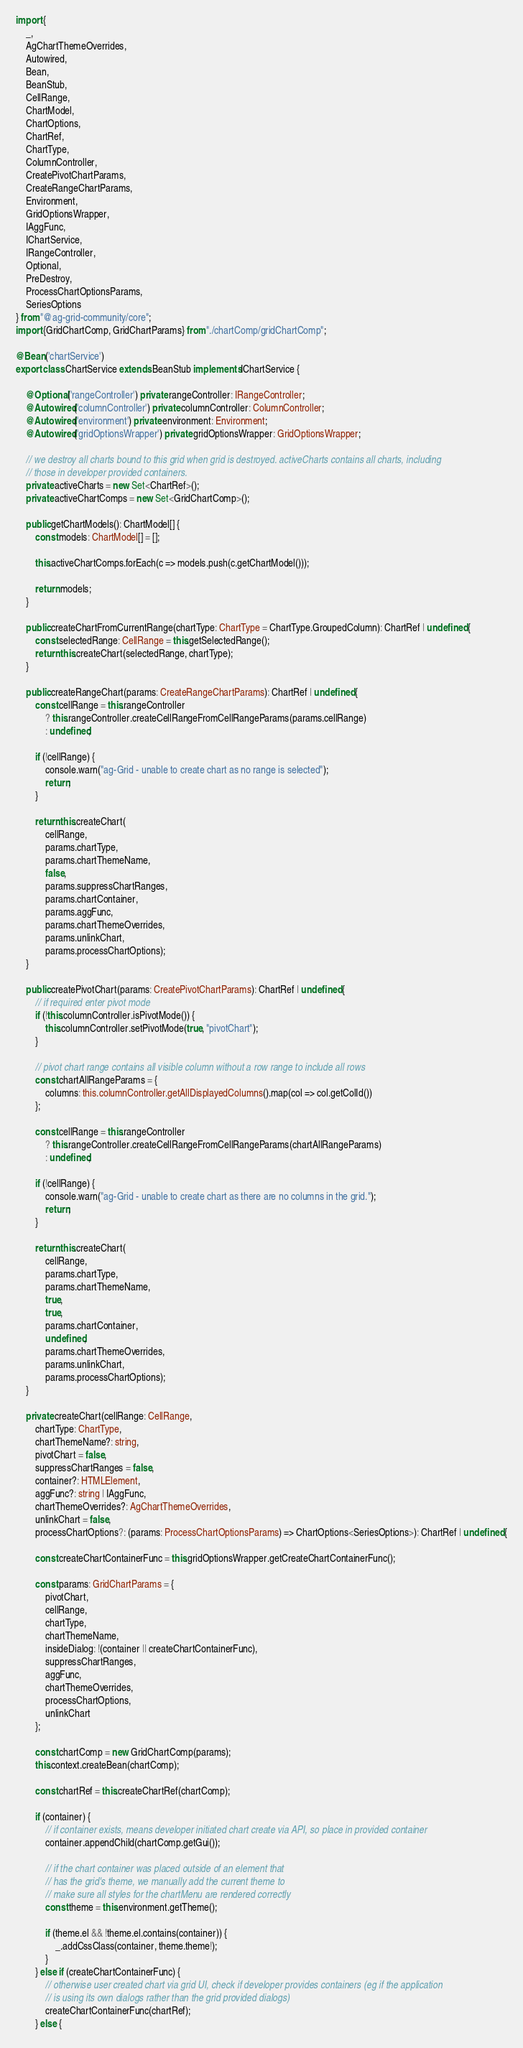Convert code to text. <code><loc_0><loc_0><loc_500><loc_500><_TypeScript_>import {
    _,
    AgChartThemeOverrides,
    Autowired,
    Bean,
    BeanStub,
    CellRange,
    ChartModel,
    ChartOptions,
    ChartRef,
    ChartType,
    ColumnController,
    CreatePivotChartParams,
    CreateRangeChartParams,
    Environment,
    GridOptionsWrapper,
    IAggFunc,
    IChartService,
    IRangeController,
    Optional,
    PreDestroy,
    ProcessChartOptionsParams,
    SeriesOptions
} from "@ag-grid-community/core";
import {GridChartComp, GridChartParams} from "./chartComp/gridChartComp";

@Bean('chartService')
export class ChartService extends BeanStub implements IChartService {

    @Optional('rangeController') private rangeController: IRangeController;
    @Autowired('columnController') private columnController: ColumnController;
    @Autowired('environment') private environment: Environment;
    @Autowired('gridOptionsWrapper') private gridOptionsWrapper: GridOptionsWrapper;

    // we destroy all charts bound to this grid when grid is destroyed. activeCharts contains all charts, including
    // those in developer provided containers.
    private activeCharts = new Set<ChartRef>();
    private activeChartComps = new Set<GridChartComp>();

    public getChartModels(): ChartModel[] {
        const models: ChartModel[] = [];

        this.activeChartComps.forEach(c => models.push(c.getChartModel()));

        return models;
    }

    public createChartFromCurrentRange(chartType: ChartType = ChartType.GroupedColumn): ChartRef | undefined {
        const selectedRange: CellRange = this.getSelectedRange();
        return this.createChart(selectedRange, chartType);
    }

    public createRangeChart(params: CreateRangeChartParams): ChartRef | undefined {
        const cellRange = this.rangeController
            ? this.rangeController.createCellRangeFromCellRangeParams(params.cellRange)
            : undefined;

        if (!cellRange) {
            console.warn("ag-Grid - unable to create chart as no range is selected");
            return;
        }

        return this.createChart(
            cellRange,
            params.chartType,
            params.chartThemeName,
            false,
            params.suppressChartRanges,
            params.chartContainer,
            params.aggFunc,
            params.chartThemeOverrides,
            params.unlinkChart,
            params.processChartOptions);
    }

    public createPivotChart(params: CreatePivotChartParams): ChartRef | undefined {
        // if required enter pivot mode
        if (!this.columnController.isPivotMode()) {
            this.columnController.setPivotMode(true, "pivotChart");
        }

        // pivot chart range contains all visible column without a row range to include all rows
        const chartAllRangeParams = {
            columns: this.columnController.getAllDisplayedColumns().map(col => col.getColId())
        };

        const cellRange = this.rangeController
            ? this.rangeController.createCellRangeFromCellRangeParams(chartAllRangeParams)
            : undefined;

        if (!cellRange) {
            console.warn("ag-Grid - unable to create chart as there are no columns in the grid.");
            return;
        }

        return this.createChart(
            cellRange,
            params.chartType,
            params.chartThemeName,
            true,
            true,
            params.chartContainer,
            undefined,
            params.chartThemeOverrides,
            params.unlinkChart,
            params.processChartOptions);
    }

    private createChart(cellRange: CellRange,
        chartType: ChartType,
        chartThemeName?: string,
        pivotChart = false,
        suppressChartRanges = false,
        container?: HTMLElement,
        aggFunc?: string | IAggFunc,
        chartThemeOverrides?: AgChartThemeOverrides,
        unlinkChart = false,
        processChartOptions?: (params: ProcessChartOptionsParams) => ChartOptions<SeriesOptions>): ChartRef | undefined {

        const createChartContainerFunc = this.gridOptionsWrapper.getCreateChartContainerFunc();

        const params: GridChartParams = {
            pivotChart,
            cellRange,
            chartType,
            chartThemeName,
            insideDialog: !(container || createChartContainerFunc),
            suppressChartRanges,
            aggFunc,
            chartThemeOverrides,
            processChartOptions,
            unlinkChart
        };

        const chartComp = new GridChartComp(params);
        this.context.createBean(chartComp);

        const chartRef = this.createChartRef(chartComp);

        if (container) {
            // if container exists, means developer initiated chart create via API, so place in provided container
            container.appendChild(chartComp.getGui());

            // if the chart container was placed outside of an element that
            // has the grid's theme, we manually add the current theme to
            // make sure all styles for the chartMenu are rendered correctly
            const theme = this.environment.getTheme();

            if (theme.el && !theme.el.contains(container)) {
                _.addCssClass(container, theme.theme!);
            }
        } else if (createChartContainerFunc) {
            // otherwise user created chart via grid UI, check if developer provides containers (eg if the application
            // is using its own dialogs rather than the grid provided dialogs)
            createChartContainerFunc(chartRef);
        } else {</code> 